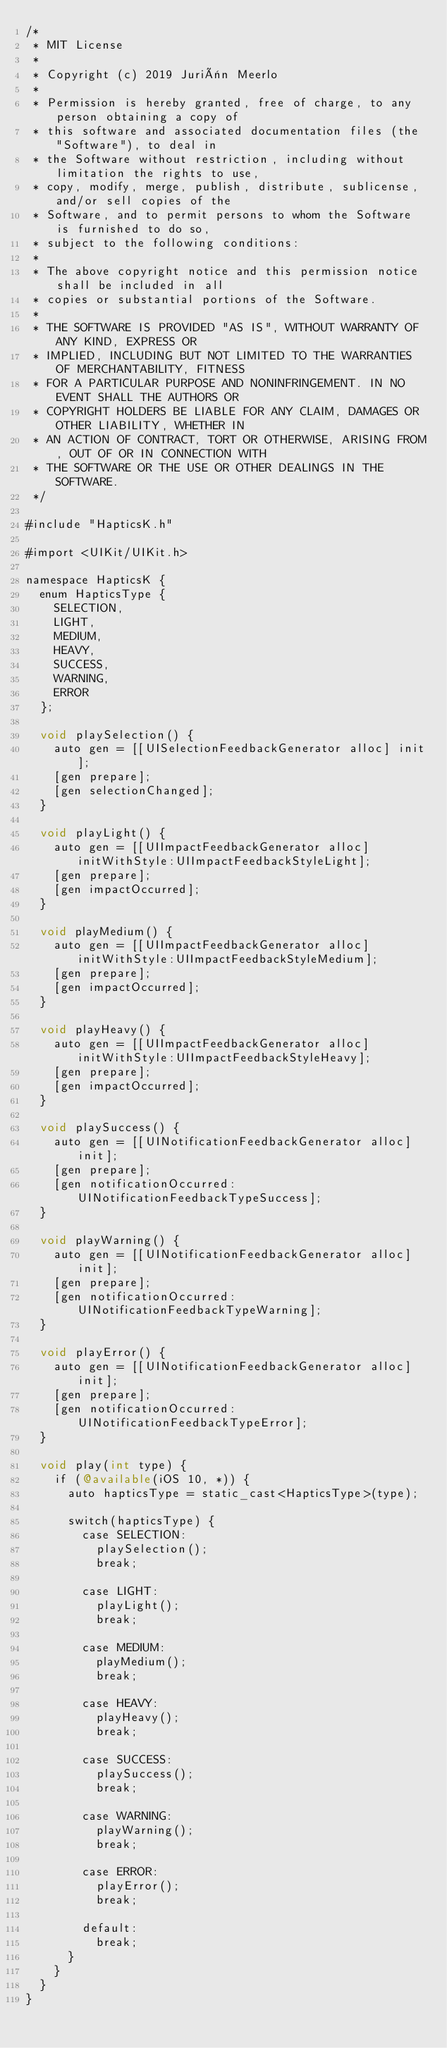<code> <loc_0><loc_0><loc_500><loc_500><_ObjectiveC_>/*
 * MIT License
 *
 * Copyright (c) 2019 Juriën Meerlo
 *
 * Permission is hereby granted, free of charge, to any person obtaining a copy of
 * this software and associated documentation files (the "Software"), to deal in
 * the Software without restriction, including without limitation the rights to use,
 * copy, modify, merge, publish, distribute, sublicense, and/or sell copies of the
 * Software, and to permit persons to whom the Software is furnished to do so,
 * subject to the following conditions:
 *
 * The above copyright notice and this permission notice shall be included in all
 * copies or substantial portions of the Software.
 *
 * THE SOFTWARE IS PROVIDED "AS IS", WITHOUT WARRANTY OF ANY KIND, EXPRESS OR
 * IMPLIED, INCLUDING BUT NOT LIMITED TO THE WARRANTIES OF MERCHANTABILITY, FITNESS
 * FOR A PARTICULAR PURPOSE AND NONINFRINGEMENT. IN NO EVENT SHALL THE AUTHORS OR
 * COPYRIGHT HOLDERS BE LIABLE FOR ANY CLAIM, DAMAGES OR OTHER LIABILITY, WHETHER IN
 * AN ACTION OF CONTRACT, TORT OR OTHERWISE, ARISING FROM, OUT OF OR IN CONNECTION WITH
 * THE SOFTWARE OR THE USE OR OTHER DEALINGS IN THE SOFTWARE.
 */

#include "HapticsK.h"

#import <UIKit/UIKit.h>

namespace HapticsK {
  enum HapticsType {
    SELECTION,
    LIGHT,
    MEDIUM,
    HEAVY,
    SUCCESS,
    WARNING,
    ERROR
  };

  void playSelection() {
    auto gen = [[UISelectionFeedbackGenerator alloc] init];
    [gen prepare];
    [gen selectionChanged];
  }

  void playLight() {
    auto gen = [[UIImpactFeedbackGenerator alloc] initWithStyle:UIImpactFeedbackStyleLight];
    [gen prepare];
    [gen impactOccurred];
  }

  void playMedium() {
    auto gen = [[UIImpactFeedbackGenerator alloc] initWithStyle:UIImpactFeedbackStyleMedium];
    [gen prepare];
    [gen impactOccurred];
  }

  void playHeavy() {
    auto gen = [[UIImpactFeedbackGenerator alloc] initWithStyle:UIImpactFeedbackStyleHeavy];
    [gen prepare];
    [gen impactOccurred];
  }

  void playSuccess() {
    auto gen = [[UINotificationFeedbackGenerator alloc] init];
    [gen prepare];
    [gen notificationOccurred:UINotificationFeedbackTypeSuccess];
  }

  void playWarning() {
    auto gen = [[UINotificationFeedbackGenerator alloc] init];
    [gen prepare];
    [gen notificationOccurred:UINotificationFeedbackTypeWarning];
  }

  void playError() {
    auto gen = [[UINotificationFeedbackGenerator alloc] init];
    [gen prepare];
    [gen notificationOccurred:UINotificationFeedbackTypeError];
  }

  void play(int type) {
    if (@available(iOS 10, *)) {
      auto hapticsType = static_cast<HapticsType>(type);

      switch(hapticsType) {
        case SELECTION:
          playSelection();
          break;

        case LIGHT:
          playLight();
          break;

        case MEDIUM:
          playMedium();
          break;

        case HEAVY:
          playHeavy();
          break;

        case SUCCESS:
          playSuccess();
          break;

        case WARNING:
          playWarning();
          break;

        case ERROR:
          playError();
          break;

        default:
          break;
      }
    }
  }
}
</code> 